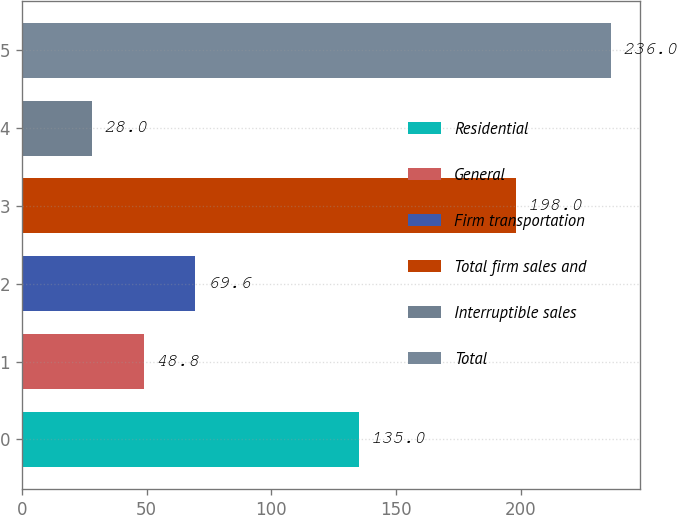Convert chart. <chart><loc_0><loc_0><loc_500><loc_500><bar_chart><fcel>Residential<fcel>General<fcel>Firm transportation<fcel>Total firm sales and<fcel>Interruptible sales<fcel>Total<nl><fcel>135<fcel>48.8<fcel>69.6<fcel>198<fcel>28<fcel>236<nl></chart> 